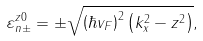Convert formula to latex. <formula><loc_0><loc_0><loc_500><loc_500>\varepsilon ^ { z 0 } _ { n \pm } = \pm \sqrt { \left ( \hbar { v } _ { F } \right ) ^ { 2 } \left ( k _ { x } ^ { 2 } - z ^ { 2 } \right ) } ,</formula> 